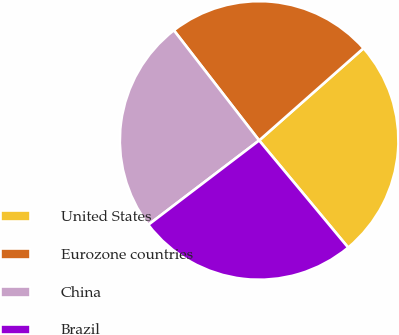Convert chart to OTSL. <chart><loc_0><loc_0><loc_500><loc_500><pie_chart><fcel>United States<fcel>Eurozone countries<fcel>China<fcel>Brazil<nl><fcel>25.48%<fcel>23.97%<fcel>24.87%<fcel>25.68%<nl></chart> 